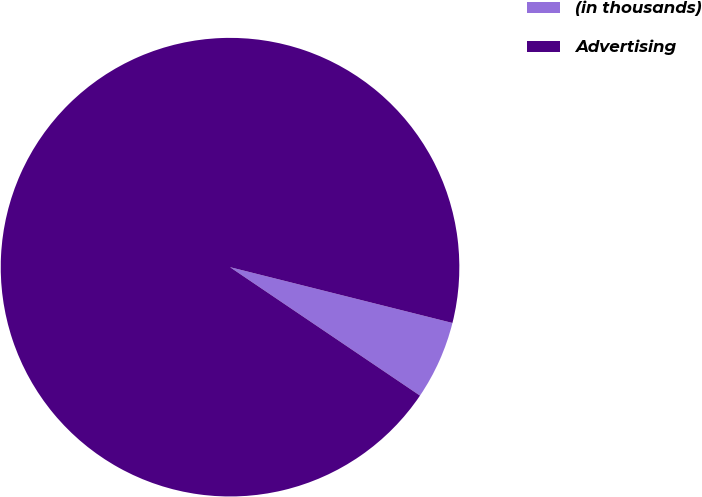Convert chart to OTSL. <chart><loc_0><loc_0><loc_500><loc_500><pie_chart><fcel>(in thousands)<fcel>Advertising<nl><fcel>5.55%<fcel>94.45%<nl></chart> 